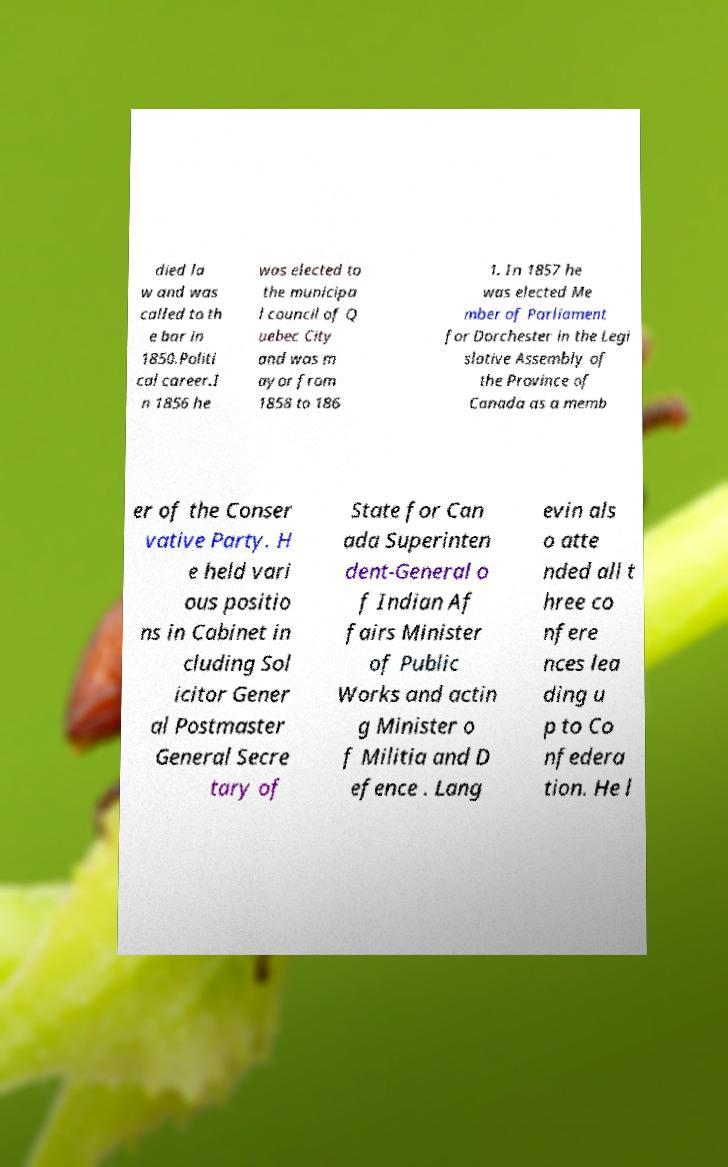Please identify and transcribe the text found in this image. died la w and was called to th e bar in 1850.Politi cal career.I n 1856 he was elected to the municipa l council of Q uebec City and was m ayor from 1858 to 186 1. In 1857 he was elected Me mber of Parliament for Dorchester in the Legi slative Assembly of the Province of Canada as a memb er of the Conser vative Party. H e held vari ous positio ns in Cabinet in cluding Sol icitor Gener al Postmaster General Secre tary of State for Can ada Superinten dent-General o f Indian Af fairs Minister of Public Works and actin g Minister o f Militia and D efence . Lang evin als o atte nded all t hree co nfere nces lea ding u p to Co nfedera tion. He l 